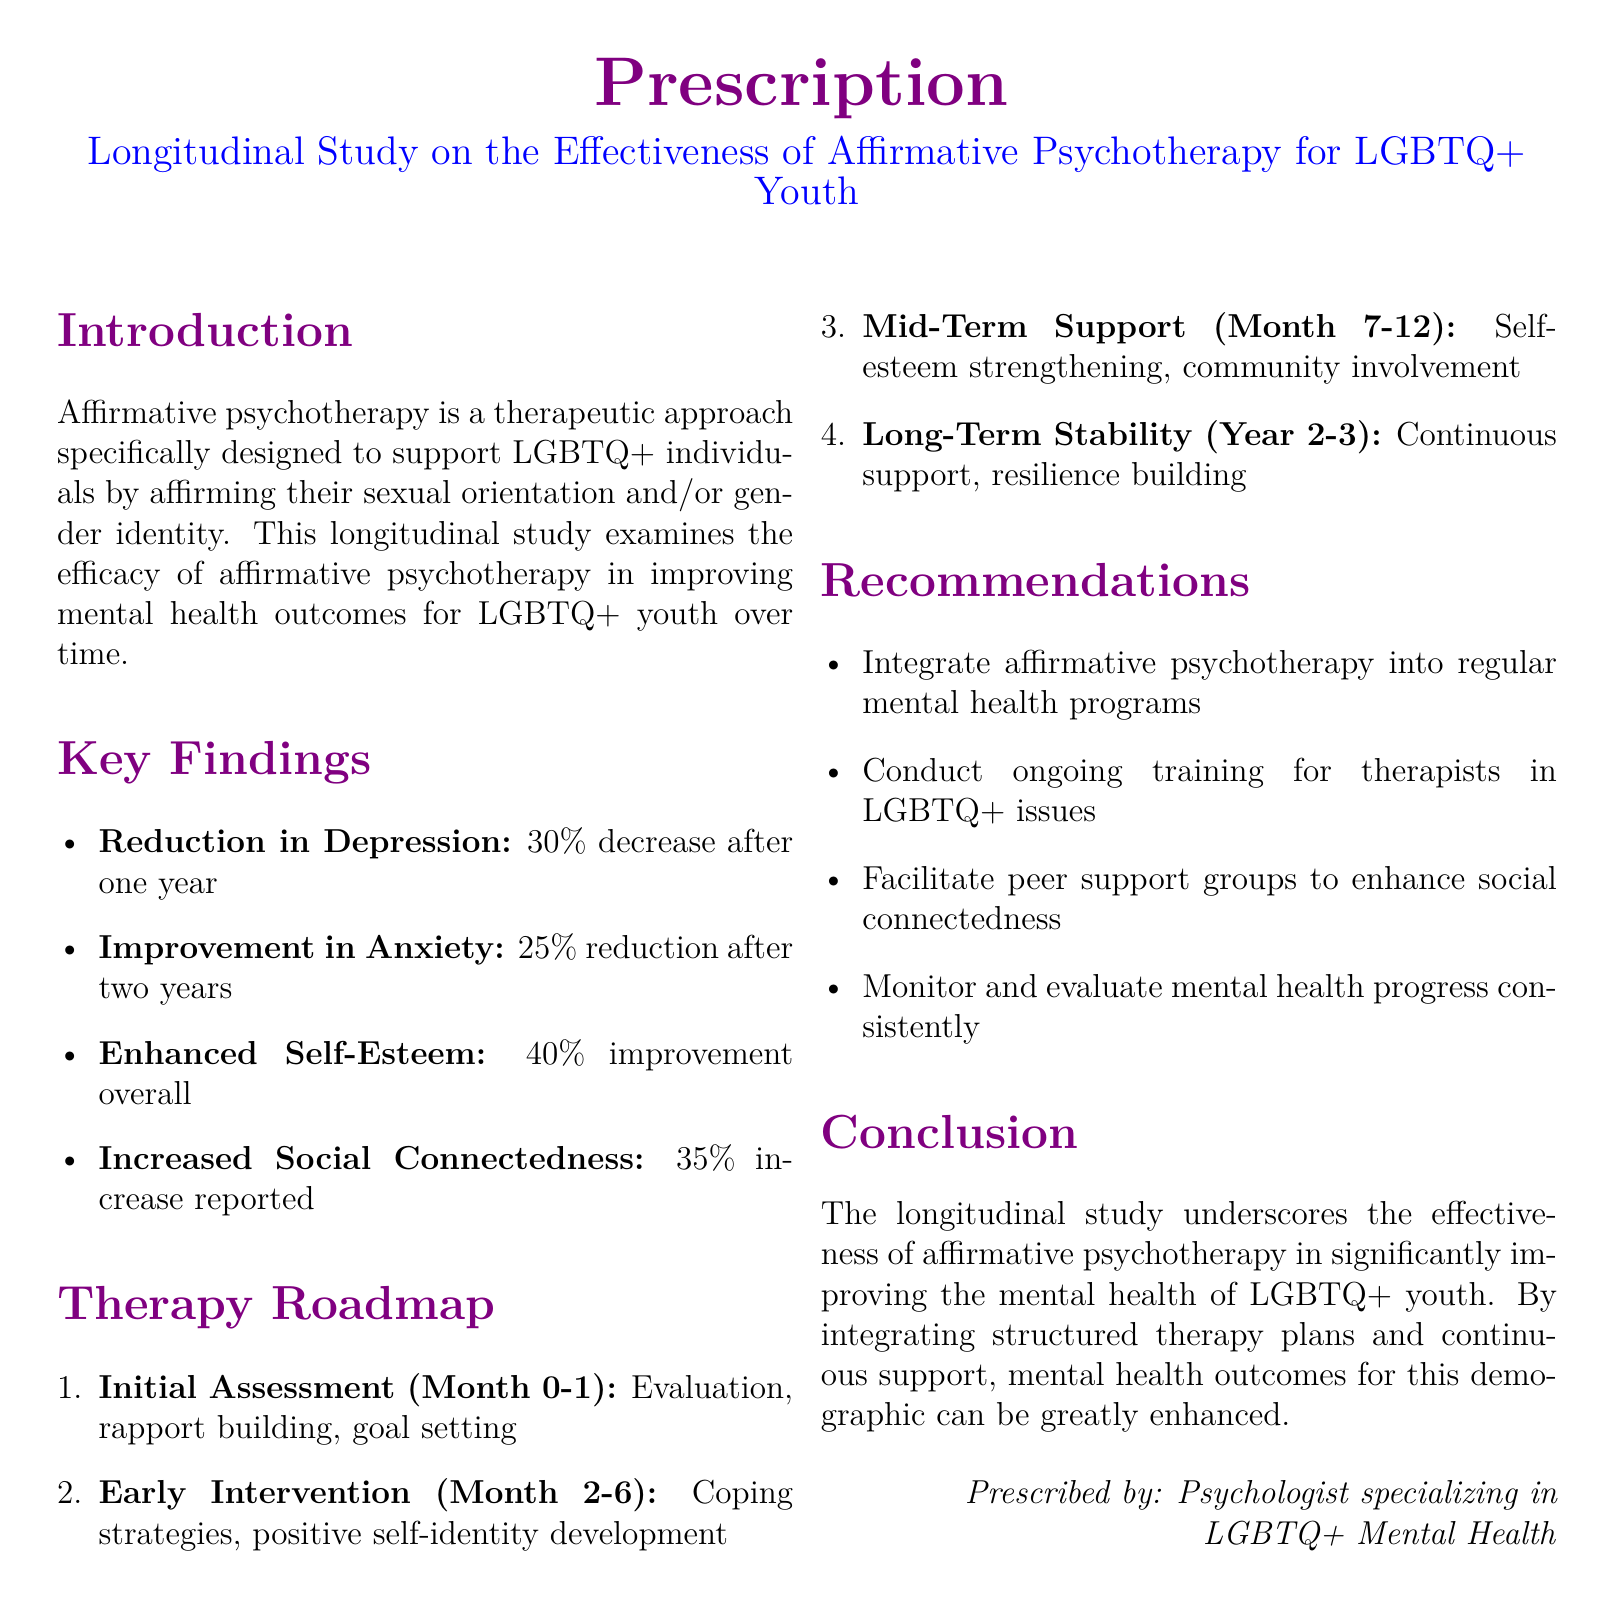what is the title of the study? The title is the main heading that describes the focus of the research in the document.
Answer: Longitudinal Study on the Effectiveness of Affirmative Psychotherapy for LGBTQ+ Youth what percentage did depression decrease after one year? This percentage represents the reduction in depression as mentioned in the key findings section.
Answer: 30% what is the goal of the initial assessment phase? The goal of this phase is outlined in the therapy roadmap as it sets the foundation for the therapeutic process.
Answer: Evaluation, rapport building, goal setting how much improvement in self-esteem was reported overall? This number is highlighted in the key findings as a significant positive outcome of the therapy.
Answer: 40% what is one of the recommendations regarding therapist training? This recommendation is aimed at improving the effectiveness of therapy as discussed in the recommendations section.
Answer: Conduct ongoing training for therapists in LGBTQ+ issues what improvement in anxiety was observed after two years? This improvement refers to the reduction in anxiety as discussed in the findings.
Answer: 25% what does the therapy roadmap suggest for Year 2-3? The information indicates the planned focus during those years as per the roadmap.
Answer: Continuous support, resilience building what was the percentage increase in social connectedness? This percentage indicates the improvement in social relationships as noted in the findings.
Answer: 35% 